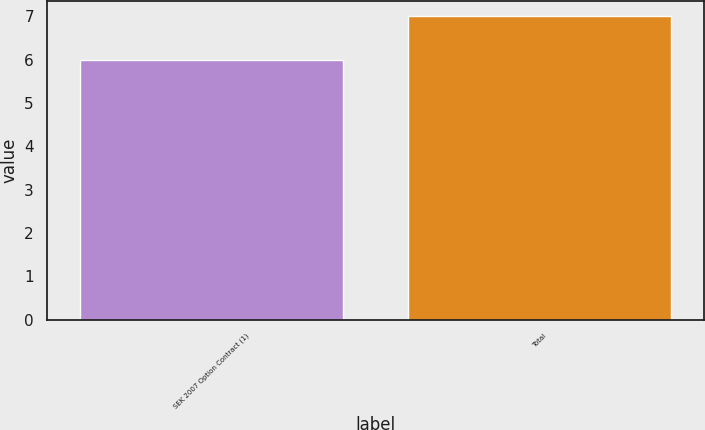<chart> <loc_0><loc_0><loc_500><loc_500><bar_chart><fcel>SEK 2007 Option Contract (1)<fcel>Total<nl><fcel>6<fcel>7<nl></chart> 